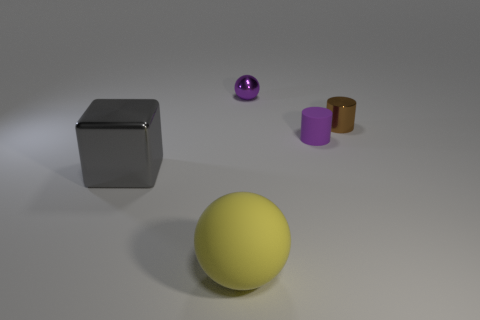Add 5 brown things. How many objects exist? 10 Subtract all balls. How many objects are left? 3 Add 1 tiny balls. How many tiny balls exist? 2 Subtract 0 green cylinders. How many objects are left? 5 Subtract all large red matte cylinders. Subtract all tiny purple shiny spheres. How many objects are left? 4 Add 5 big gray metallic blocks. How many big gray metallic blocks are left? 6 